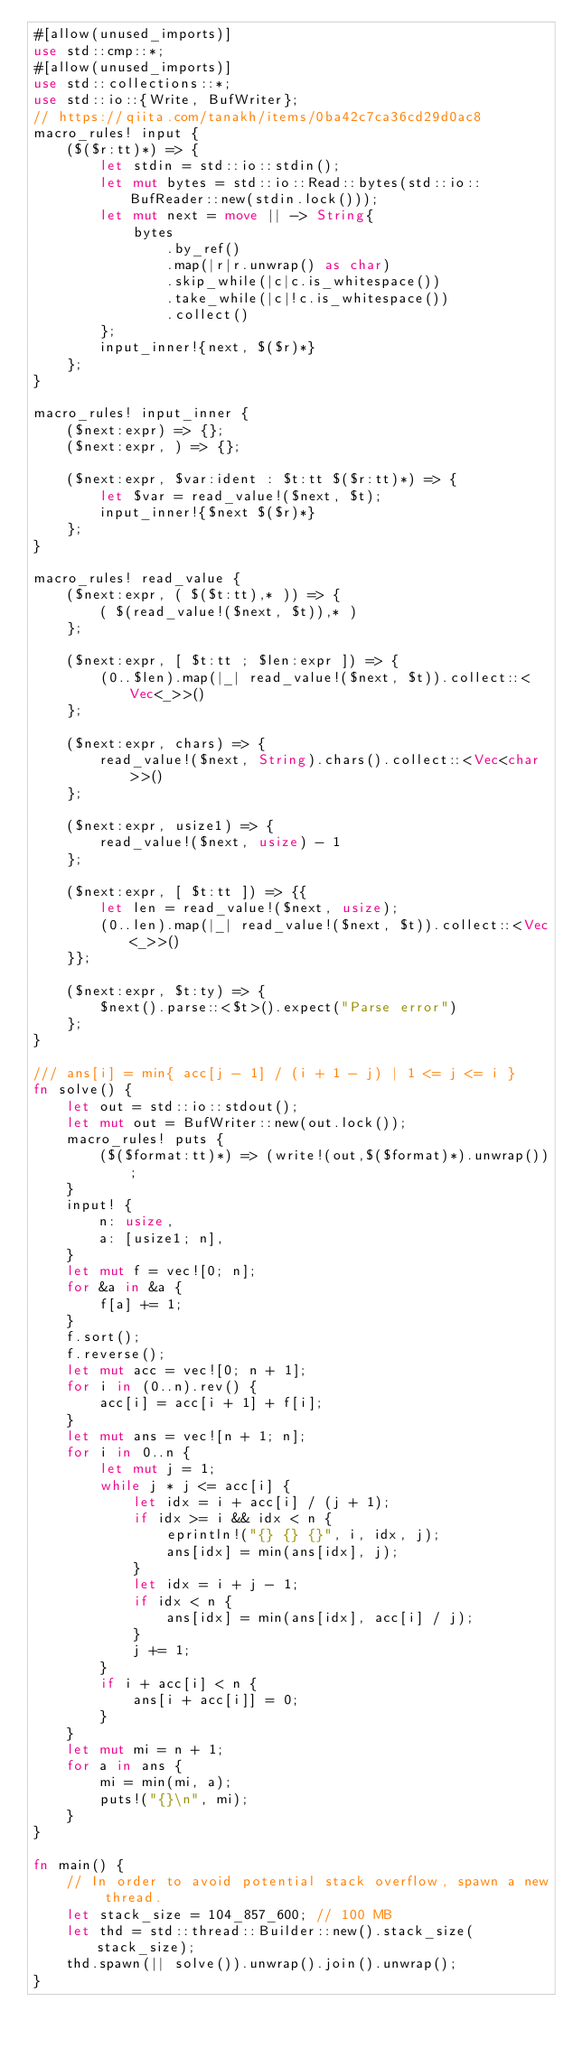<code> <loc_0><loc_0><loc_500><loc_500><_Rust_>#[allow(unused_imports)]
use std::cmp::*;
#[allow(unused_imports)]
use std::collections::*;
use std::io::{Write, BufWriter};
// https://qiita.com/tanakh/items/0ba42c7ca36cd29d0ac8
macro_rules! input {
    ($($r:tt)*) => {
        let stdin = std::io::stdin();
        let mut bytes = std::io::Read::bytes(std::io::BufReader::new(stdin.lock()));
        let mut next = move || -> String{
            bytes
                .by_ref()
                .map(|r|r.unwrap() as char)
                .skip_while(|c|c.is_whitespace())
                .take_while(|c|!c.is_whitespace())
                .collect()
        };
        input_inner!{next, $($r)*}
    };
}

macro_rules! input_inner {
    ($next:expr) => {};
    ($next:expr, ) => {};

    ($next:expr, $var:ident : $t:tt $($r:tt)*) => {
        let $var = read_value!($next, $t);
        input_inner!{$next $($r)*}
    };
}

macro_rules! read_value {
    ($next:expr, ( $($t:tt),* )) => {
        ( $(read_value!($next, $t)),* )
    };

    ($next:expr, [ $t:tt ; $len:expr ]) => {
        (0..$len).map(|_| read_value!($next, $t)).collect::<Vec<_>>()
    };

    ($next:expr, chars) => {
        read_value!($next, String).chars().collect::<Vec<char>>()
    };

    ($next:expr, usize1) => {
        read_value!($next, usize) - 1
    };

    ($next:expr, [ $t:tt ]) => {{
        let len = read_value!($next, usize);
        (0..len).map(|_| read_value!($next, $t)).collect::<Vec<_>>()
    }};

    ($next:expr, $t:ty) => {
        $next().parse::<$t>().expect("Parse error")
    };
}

/// ans[i] = min{ acc[j - 1] / (i + 1 - j) | 1 <= j <= i }
fn solve() {
    let out = std::io::stdout();
    let mut out = BufWriter::new(out.lock());
    macro_rules! puts {
        ($($format:tt)*) => (write!(out,$($format)*).unwrap());
    }
    input! {
        n: usize,
        a: [usize1; n],
    }
    let mut f = vec![0; n];
    for &a in &a {
        f[a] += 1;
    }
    f.sort();
    f.reverse();
    let mut acc = vec![0; n + 1];
    for i in (0..n).rev() {
        acc[i] = acc[i + 1] + f[i];
    }
    let mut ans = vec![n + 1; n];
    for i in 0..n {
        let mut j = 1;
        while j * j <= acc[i] {
            let idx = i + acc[i] / (j + 1);
            if idx >= i && idx < n {
                eprintln!("{} {} {}", i, idx, j);
                ans[idx] = min(ans[idx], j);
            }
            let idx = i + j - 1;
            if idx < n {
                ans[idx] = min(ans[idx], acc[i] / j);
            }
            j += 1;
        }
        if i + acc[i] < n {
            ans[i + acc[i]] = 0;
        }
    }
    let mut mi = n + 1;
    for a in ans {
        mi = min(mi, a);
        puts!("{}\n", mi);
    }
}

fn main() {
    // In order to avoid potential stack overflow, spawn a new thread.
    let stack_size = 104_857_600; // 100 MB
    let thd = std::thread::Builder::new().stack_size(stack_size);
    thd.spawn(|| solve()).unwrap().join().unwrap();
}
</code> 